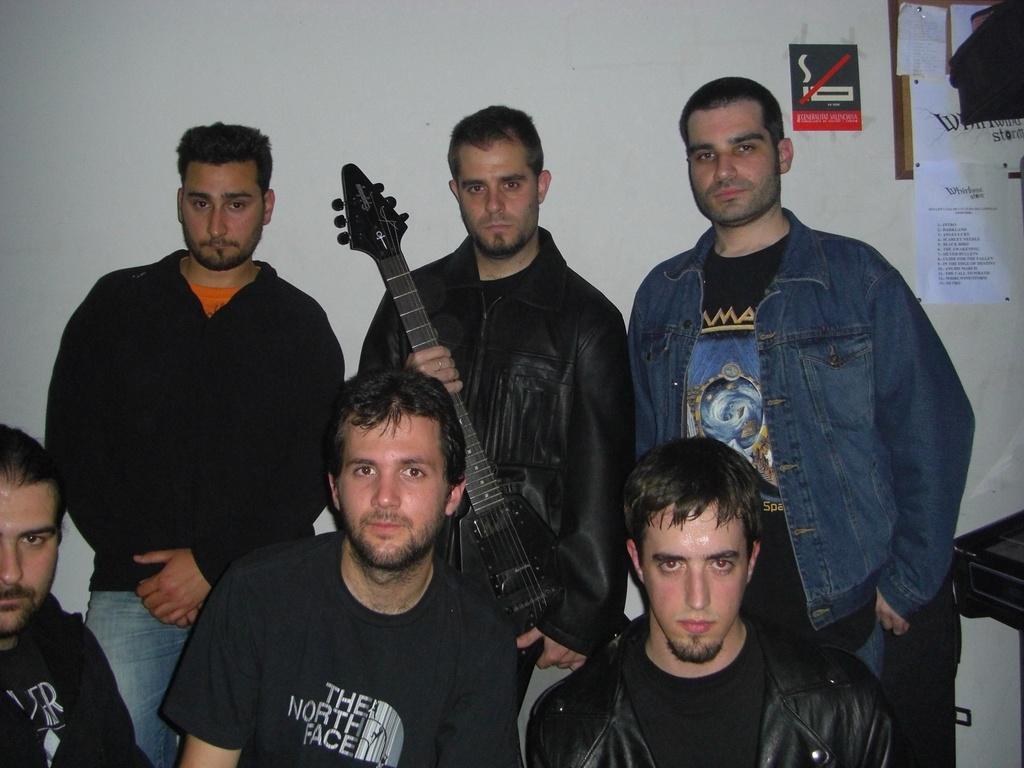In one or two sentences, can you explain what this image depicts? In this image we can see six men. One man is holding a guitar in his hand. There is a white color wall in the background. We can see a notice board and a sign board in the right top of the image. On the right side of the image, we can see a black color object. 